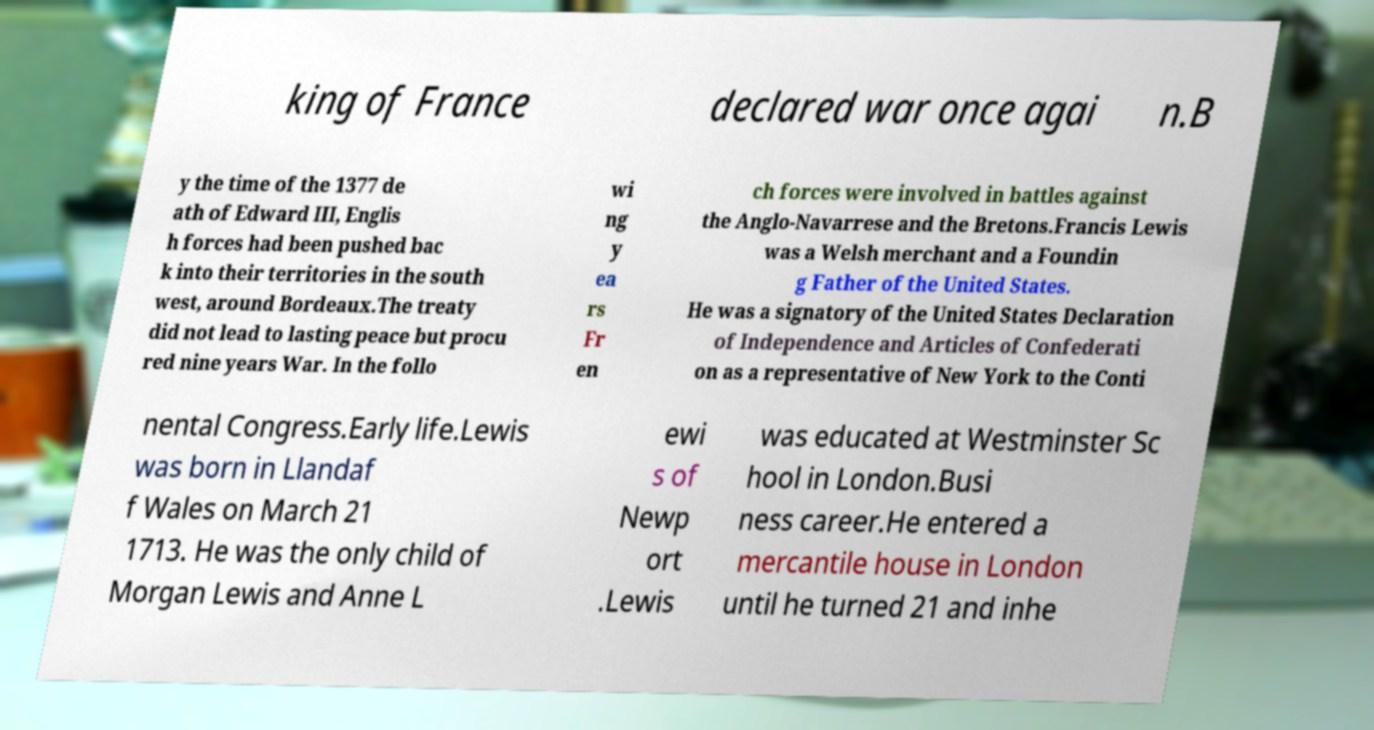I need the written content from this picture converted into text. Can you do that? king of France declared war once agai n.B y the time of the 1377 de ath of Edward III, Englis h forces had been pushed bac k into their territories in the south west, around Bordeaux.The treaty did not lead to lasting peace but procu red nine years War. In the follo wi ng y ea rs Fr en ch forces were involved in battles against the Anglo-Navarrese and the Bretons.Francis Lewis was a Welsh merchant and a Foundin g Father of the United States. He was a signatory of the United States Declaration of Independence and Articles of Confederati on as a representative of New York to the Conti nental Congress.Early life.Lewis was born in Llandaf f Wales on March 21 1713. He was the only child of Morgan Lewis and Anne L ewi s of Newp ort .Lewis was educated at Westminster Sc hool in London.Busi ness career.He entered a mercantile house in London until he turned 21 and inhe 